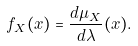Convert formula to latex. <formula><loc_0><loc_0><loc_500><loc_500>f _ { X } ( x ) = { \frac { d \mu _ { X } } { d \lambda } } ( x ) .</formula> 